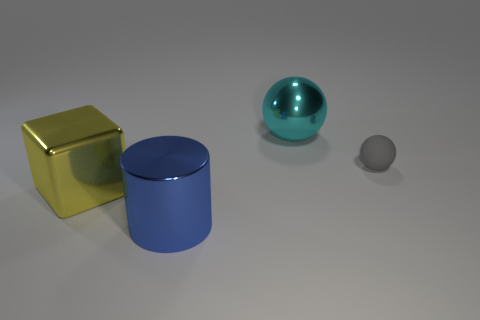Subtract all cyan spheres. How many spheres are left? 1 Subtract all blocks. How many objects are left? 3 Add 4 shiny cylinders. How many shiny cylinders exist? 5 Add 1 large red shiny objects. How many objects exist? 5 Subtract 0 cyan cubes. How many objects are left? 4 Subtract all green cubes. Subtract all green balls. How many cubes are left? 1 Subtract all cyan blocks. How many gray spheres are left? 1 Subtract all tiny yellow things. Subtract all blocks. How many objects are left? 3 Add 4 blue metallic cylinders. How many blue metallic cylinders are left? 5 